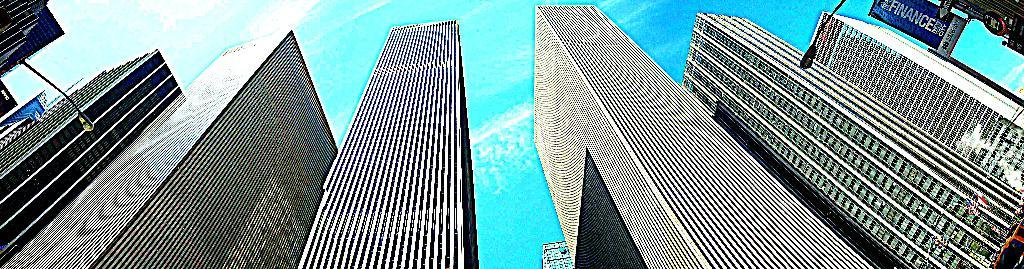What type of structures can be seen in the image? There are many buildings in the image. What type of lighting is present along the sides of the image? There are street lights on the sides of the image. What can be seen in the right corner of the image? There are banners in the right corner of the image. What is visible in the background of the image? The sky is visible in the background of the image. How many friends are riding bikes in the image? There are no friends or bikes present in the image. 